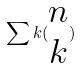<formula> <loc_0><loc_0><loc_500><loc_500>\sum k ( \begin{matrix} n \\ k \end{matrix} )</formula> 